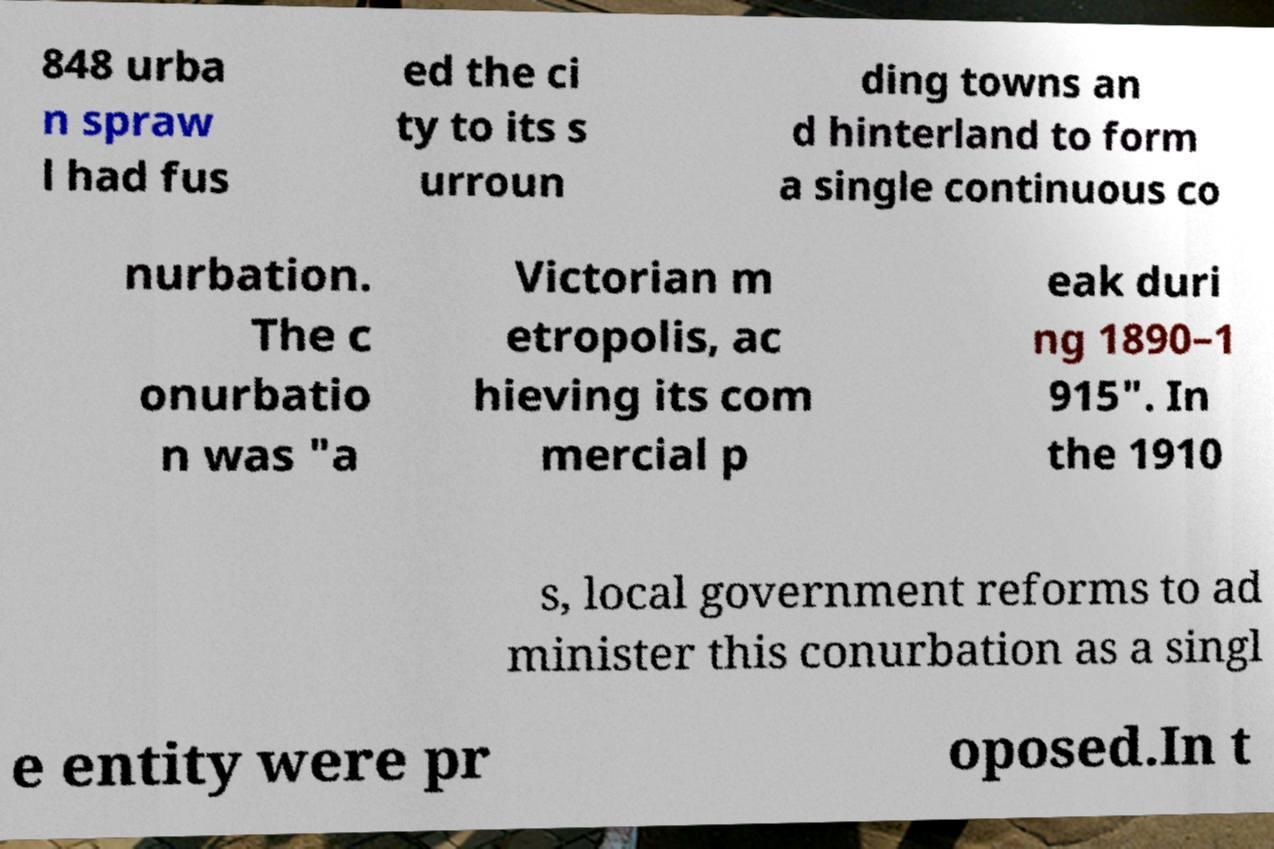Could you assist in decoding the text presented in this image and type it out clearly? 848 urba n spraw l had fus ed the ci ty to its s urroun ding towns an d hinterland to form a single continuous co nurbation. The c onurbatio n was "a Victorian m etropolis, ac hieving its com mercial p eak duri ng 1890–1 915". In the 1910 s, local government reforms to ad minister this conurbation as a singl e entity were pr oposed.In t 